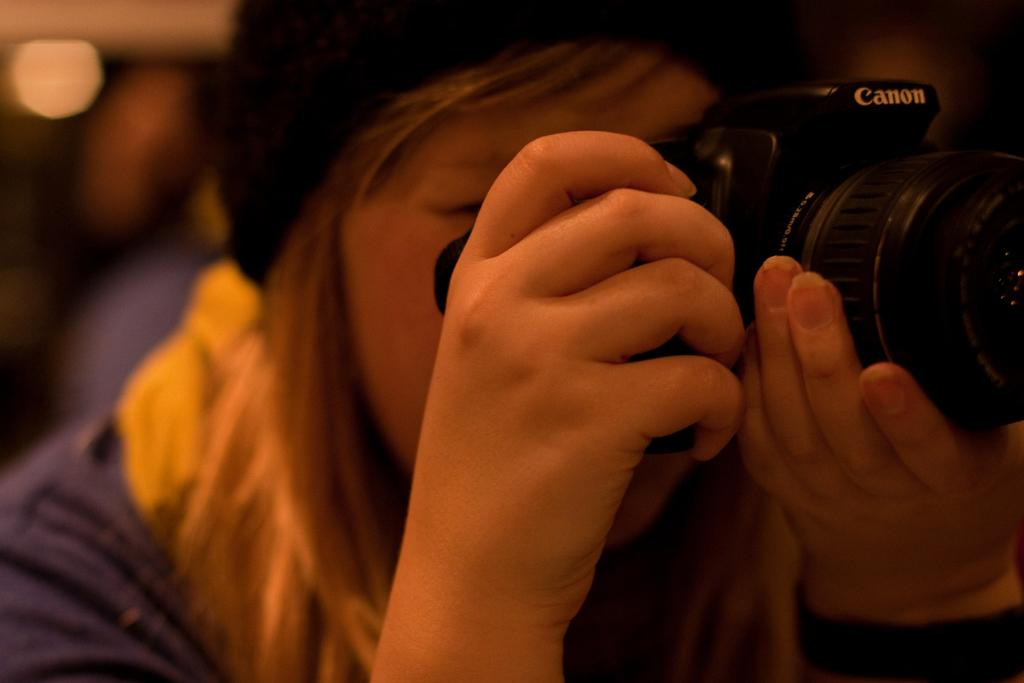Who is the main subject in the image? There is a woman in the image. What is the woman holding in the image? The woman is holding a camera. Can you describe the woman's attire in the image? The woman is wearing a cap on her head. What type of blood is visible on the edge of the mountain in the image? There is no blood or mountain present in the image; it features a woman holding a camera and wearing a cap. 